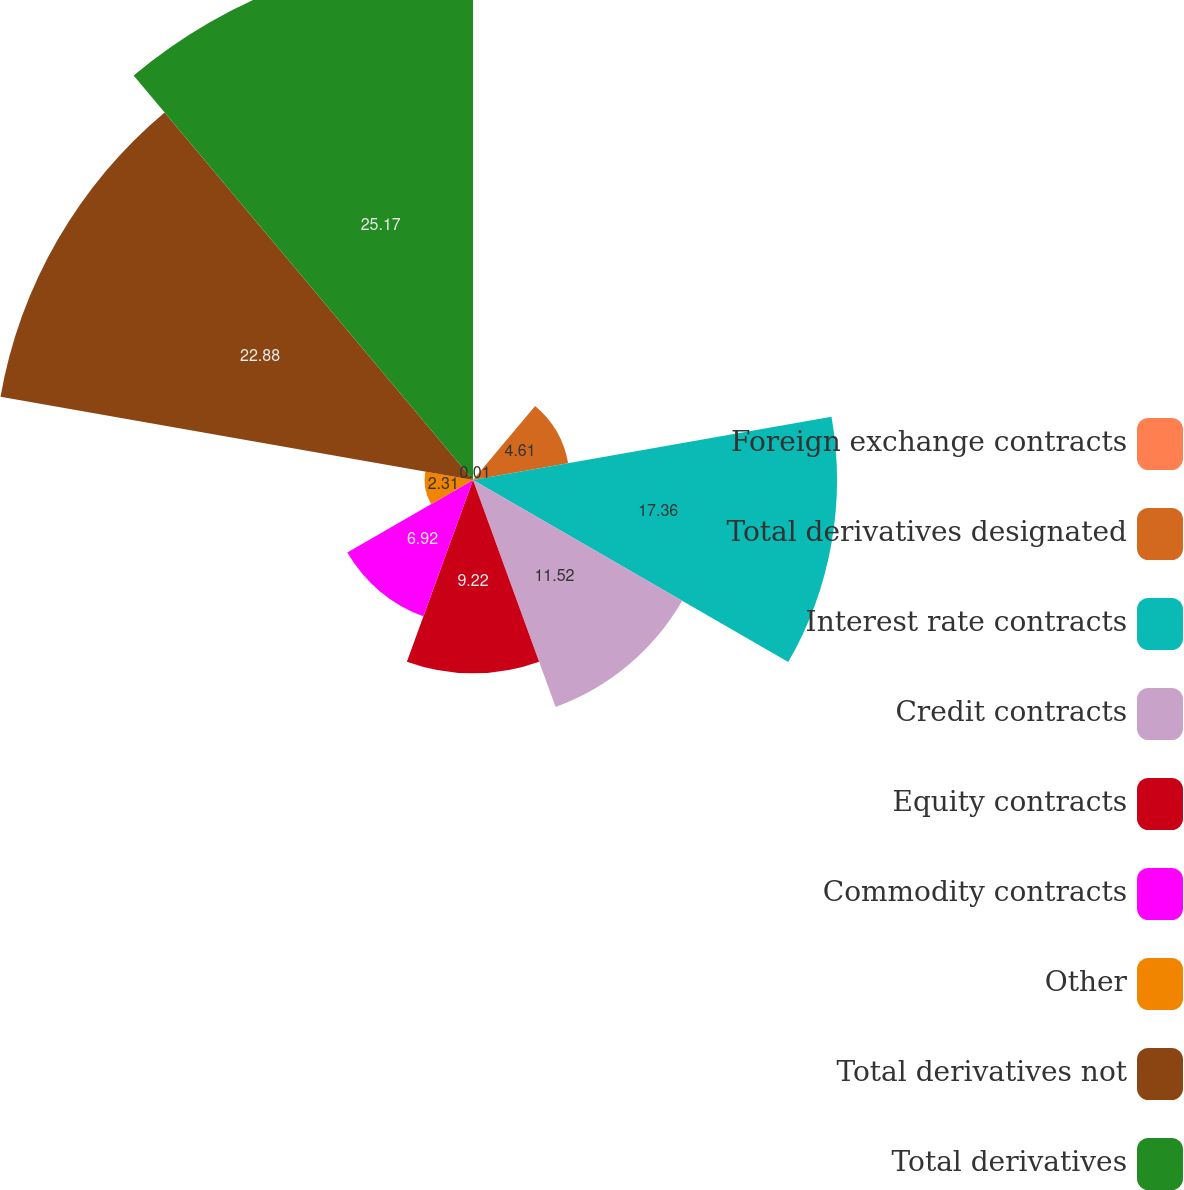Convert chart to OTSL. <chart><loc_0><loc_0><loc_500><loc_500><pie_chart><fcel>Foreign exchange contracts<fcel>Total derivatives designated<fcel>Interest rate contracts<fcel>Credit contracts<fcel>Equity contracts<fcel>Commodity contracts<fcel>Other<fcel>Total derivatives not<fcel>Total derivatives<nl><fcel>0.01%<fcel>4.61%<fcel>17.36%<fcel>11.52%<fcel>9.22%<fcel>6.92%<fcel>2.31%<fcel>22.88%<fcel>25.18%<nl></chart> 